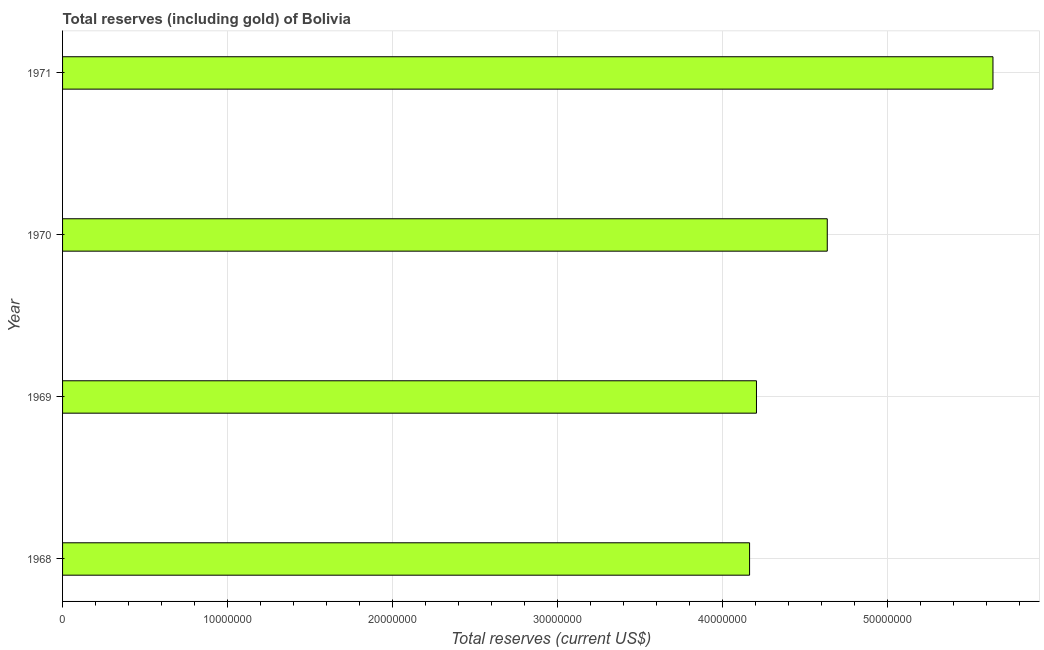Does the graph contain any zero values?
Provide a succinct answer. No. What is the title of the graph?
Provide a short and direct response. Total reserves (including gold) of Bolivia. What is the label or title of the X-axis?
Make the answer very short. Total reserves (current US$). What is the total reserves (including gold) in 1970?
Make the answer very short. 4.64e+07. Across all years, what is the maximum total reserves (including gold)?
Provide a succinct answer. 5.64e+07. Across all years, what is the minimum total reserves (including gold)?
Your response must be concise. 4.16e+07. In which year was the total reserves (including gold) maximum?
Offer a very short reply. 1971. In which year was the total reserves (including gold) minimum?
Keep it short and to the point. 1968. What is the sum of the total reserves (including gold)?
Offer a very short reply. 1.86e+08. What is the difference between the total reserves (including gold) in 1969 and 1971?
Keep it short and to the point. -1.43e+07. What is the average total reserves (including gold) per year?
Your response must be concise. 4.66e+07. What is the median total reserves (including gold)?
Your response must be concise. 4.42e+07. Do a majority of the years between 1968 and 1970 (inclusive) have total reserves (including gold) greater than 28000000 US$?
Ensure brevity in your answer.  Yes. What is the ratio of the total reserves (including gold) in 1968 to that in 1970?
Your response must be concise. 0.9. Is the difference between the total reserves (including gold) in 1970 and 1971 greater than the difference between any two years?
Give a very brief answer. No. What is the difference between the highest and the second highest total reserves (including gold)?
Ensure brevity in your answer.  1.00e+07. Is the sum of the total reserves (including gold) in 1970 and 1971 greater than the maximum total reserves (including gold) across all years?
Your answer should be very brief. Yes. What is the difference between the highest and the lowest total reserves (including gold)?
Your response must be concise. 1.48e+07. How many bars are there?
Offer a terse response. 4. Are all the bars in the graph horizontal?
Give a very brief answer. Yes. What is the difference between two consecutive major ticks on the X-axis?
Your answer should be very brief. 1.00e+07. What is the Total reserves (current US$) in 1968?
Keep it short and to the point. 4.16e+07. What is the Total reserves (current US$) of 1969?
Give a very brief answer. 4.21e+07. What is the Total reserves (current US$) in 1970?
Make the answer very short. 4.64e+07. What is the Total reserves (current US$) in 1971?
Provide a succinct answer. 5.64e+07. What is the difference between the Total reserves (current US$) in 1968 and 1969?
Provide a short and direct response. -4.18e+05. What is the difference between the Total reserves (current US$) in 1968 and 1970?
Your response must be concise. -4.71e+06. What is the difference between the Total reserves (current US$) in 1968 and 1971?
Keep it short and to the point. -1.48e+07. What is the difference between the Total reserves (current US$) in 1969 and 1970?
Your answer should be compact. -4.29e+06. What is the difference between the Total reserves (current US$) in 1969 and 1971?
Make the answer very short. -1.43e+07. What is the difference between the Total reserves (current US$) in 1970 and 1971?
Your response must be concise. -1.00e+07. What is the ratio of the Total reserves (current US$) in 1968 to that in 1969?
Your answer should be compact. 0.99. What is the ratio of the Total reserves (current US$) in 1968 to that in 1970?
Keep it short and to the point. 0.9. What is the ratio of the Total reserves (current US$) in 1968 to that in 1971?
Your answer should be very brief. 0.74. What is the ratio of the Total reserves (current US$) in 1969 to that in 1970?
Make the answer very short. 0.91. What is the ratio of the Total reserves (current US$) in 1969 to that in 1971?
Provide a short and direct response. 0.75. What is the ratio of the Total reserves (current US$) in 1970 to that in 1971?
Provide a short and direct response. 0.82. 